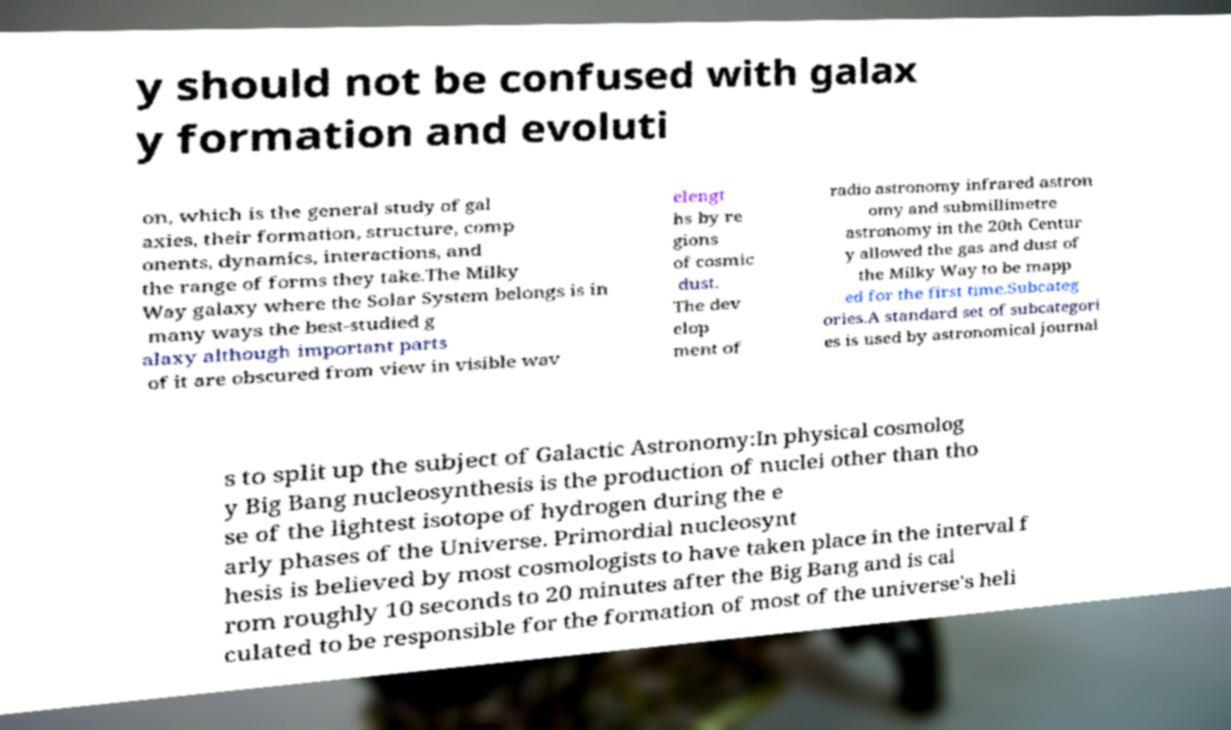Could you extract and type out the text from this image? y should not be confused with galax y formation and evoluti on, which is the general study of gal axies, their formation, structure, comp onents, dynamics, interactions, and the range of forms they take.The Milky Way galaxy where the Solar System belongs is in many ways the best-studied g alaxy although important parts of it are obscured from view in visible wav elengt hs by re gions of cosmic dust. The dev elop ment of radio astronomy infrared astron omy and submillimetre astronomy in the 20th Centur y allowed the gas and dust of the Milky Way to be mapp ed for the first time.Subcateg ories.A standard set of subcategori es is used by astronomical journal s to split up the subject of Galactic Astronomy:In physical cosmolog y Big Bang nucleosynthesis is the production of nuclei other than tho se of the lightest isotope of hydrogen during the e arly phases of the Universe. Primordial nucleosynt hesis is believed by most cosmologists to have taken place in the interval f rom roughly 10 seconds to 20 minutes after the Big Bang and is cal culated to be responsible for the formation of most of the universe's heli 